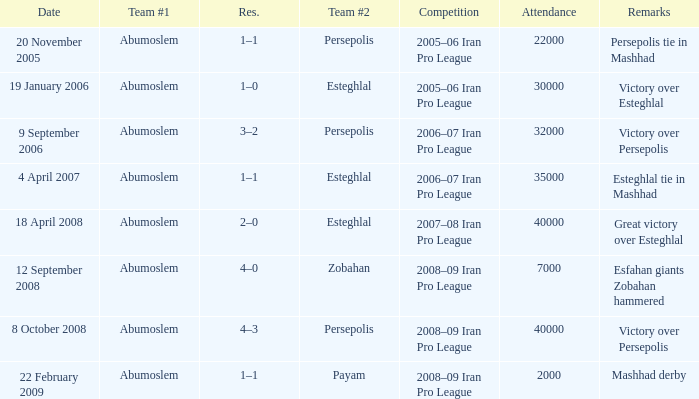What was the maximum number of attendees? 40000.0. 